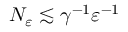<formula> <loc_0><loc_0><loc_500><loc_500>N _ { \varepsilon } \lesssim \gamma ^ { - 1 } \varepsilon ^ { - 1 }</formula> 